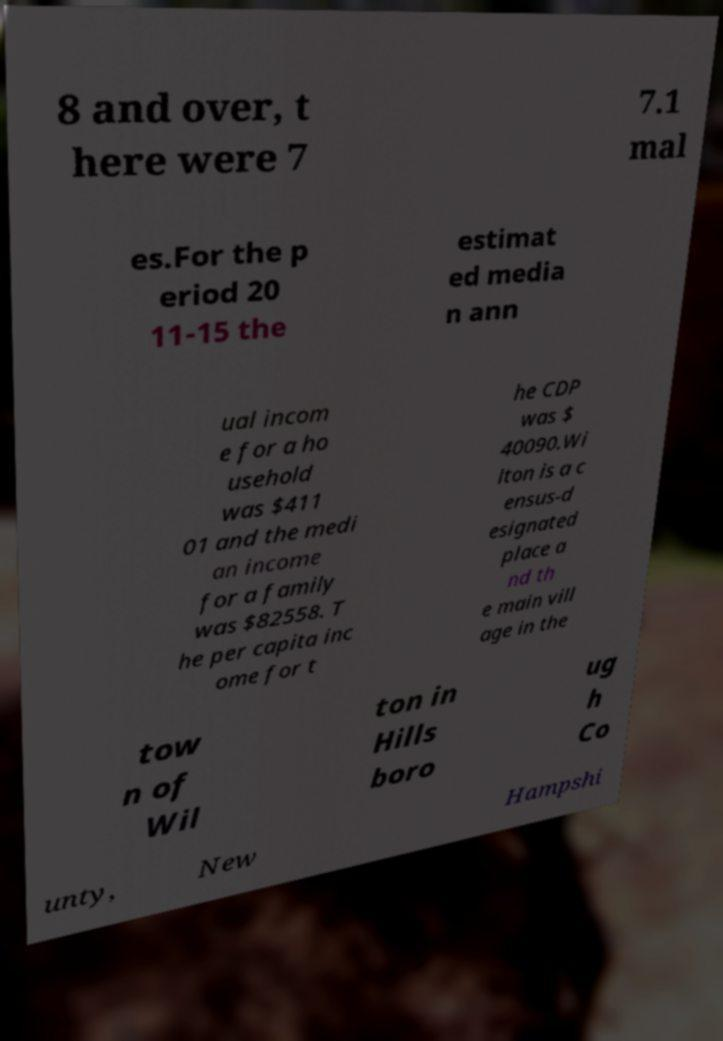Can you read and provide the text displayed in the image?This photo seems to have some interesting text. Can you extract and type it out for me? 8 and over, t here were 7 7.1 mal es.For the p eriod 20 11-15 the estimat ed media n ann ual incom e for a ho usehold was $411 01 and the medi an income for a family was $82558. T he per capita inc ome for t he CDP was $ 40090.Wi lton is a c ensus-d esignated place a nd th e main vill age in the tow n of Wil ton in Hills boro ug h Co unty, New Hampshi 